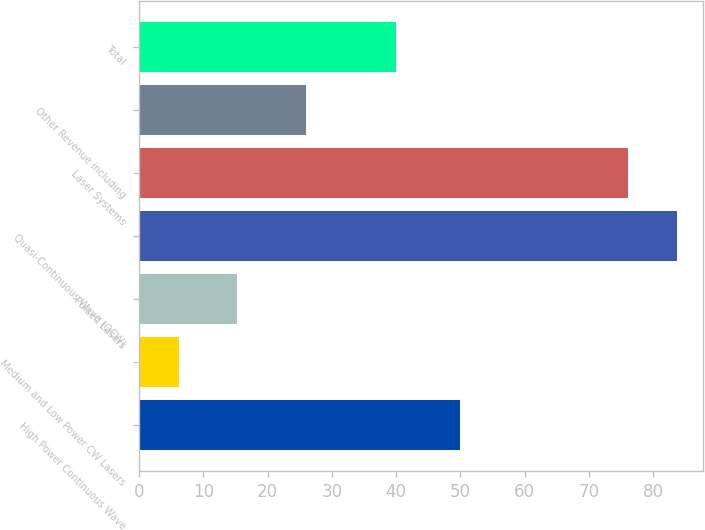Convert chart. <chart><loc_0><loc_0><loc_500><loc_500><bar_chart><fcel>High Power Continuous Wave<fcel>Medium and Low Power CW Lasers<fcel>Pulsed Lasers<fcel>Quasi-Continuous Wave (QCW)<fcel>Laser Systems<fcel>Other Revenue including<fcel>Total<nl><fcel>49.9<fcel>6.3<fcel>15.3<fcel>83.64<fcel>76.1<fcel>26<fcel>40<nl></chart> 